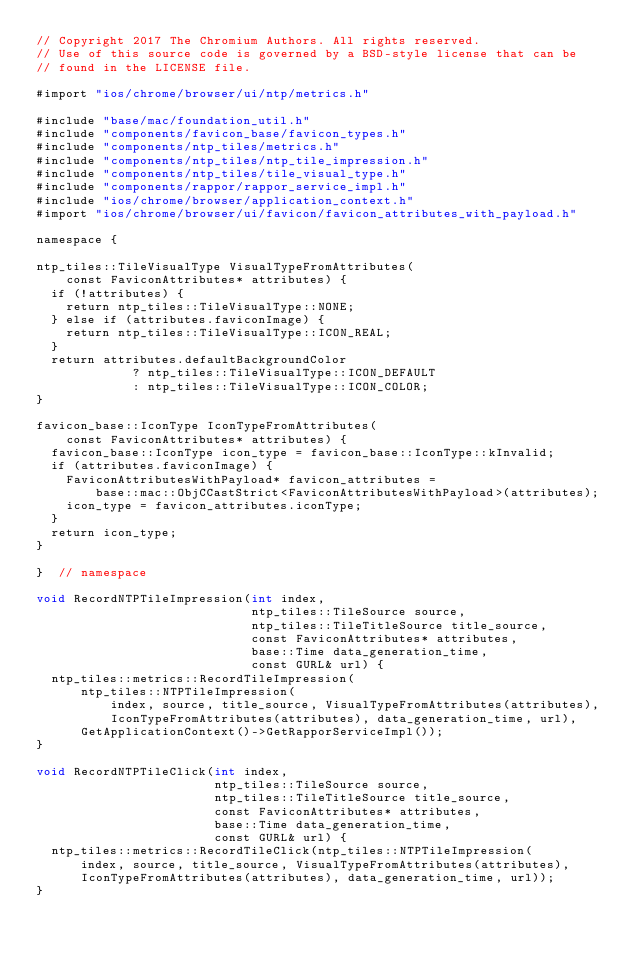Convert code to text. <code><loc_0><loc_0><loc_500><loc_500><_ObjectiveC_>// Copyright 2017 The Chromium Authors. All rights reserved.
// Use of this source code is governed by a BSD-style license that can be
// found in the LICENSE file.

#import "ios/chrome/browser/ui/ntp/metrics.h"

#include "base/mac/foundation_util.h"
#include "components/favicon_base/favicon_types.h"
#include "components/ntp_tiles/metrics.h"
#include "components/ntp_tiles/ntp_tile_impression.h"
#include "components/ntp_tiles/tile_visual_type.h"
#include "components/rappor/rappor_service_impl.h"
#include "ios/chrome/browser/application_context.h"
#import "ios/chrome/browser/ui/favicon/favicon_attributes_with_payload.h"

namespace {

ntp_tiles::TileVisualType VisualTypeFromAttributes(
    const FaviconAttributes* attributes) {
  if (!attributes) {
    return ntp_tiles::TileVisualType::NONE;
  } else if (attributes.faviconImage) {
    return ntp_tiles::TileVisualType::ICON_REAL;
  }
  return attributes.defaultBackgroundColor
             ? ntp_tiles::TileVisualType::ICON_DEFAULT
             : ntp_tiles::TileVisualType::ICON_COLOR;
}

favicon_base::IconType IconTypeFromAttributes(
    const FaviconAttributes* attributes) {
  favicon_base::IconType icon_type = favicon_base::IconType::kInvalid;
  if (attributes.faviconImage) {
    FaviconAttributesWithPayload* favicon_attributes =
        base::mac::ObjCCastStrict<FaviconAttributesWithPayload>(attributes);
    icon_type = favicon_attributes.iconType;
  }
  return icon_type;
}

}  // namespace

void RecordNTPTileImpression(int index,
                             ntp_tiles::TileSource source,
                             ntp_tiles::TileTitleSource title_source,
                             const FaviconAttributes* attributes,
                             base::Time data_generation_time,
                             const GURL& url) {
  ntp_tiles::metrics::RecordTileImpression(
      ntp_tiles::NTPTileImpression(
          index, source, title_source, VisualTypeFromAttributes(attributes),
          IconTypeFromAttributes(attributes), data_generation_time, url),
      GetApplicationContext()->GetRapporServiceImpl());
}

void RecordNTPTileClick(int index,
                        ntp_tiles::TileSource source,
                        ntp_tiles::TileTitleSource title_source,
                        const FaviconAttributes* attributes,
                        base::Time data_generation_time,
                        const GURL& url) {
  ntp_tiles::metrics::RecordTileClick(ntp_tiles::NTPTileImpression(
      index, source, title_source, VisualTypeFromAttributes(attributes),
      IconTypeFromAttributes(attributes), data_generation_time, url));
}
</code> 